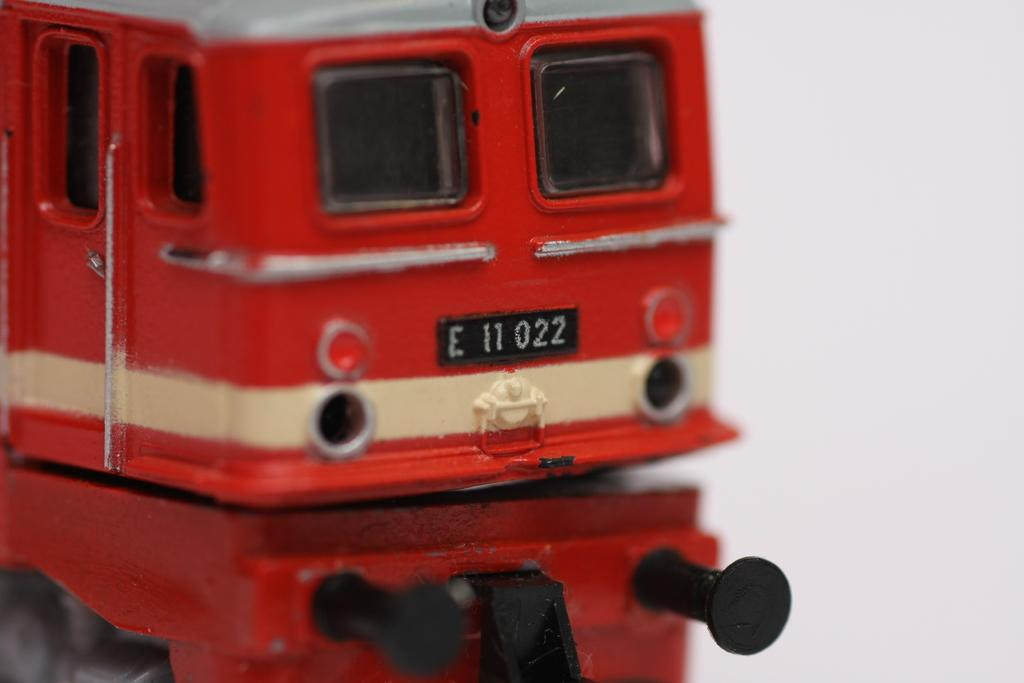What type of toy is present in the image? There is a toy vehicle in the image. Can you describe any additional features of the toy vehicle in the image? There is a reflection of the toy vehicle in the image. How many women are present in the image? There is no mention of women in the image, so it is not possible to determine their presence or number. 